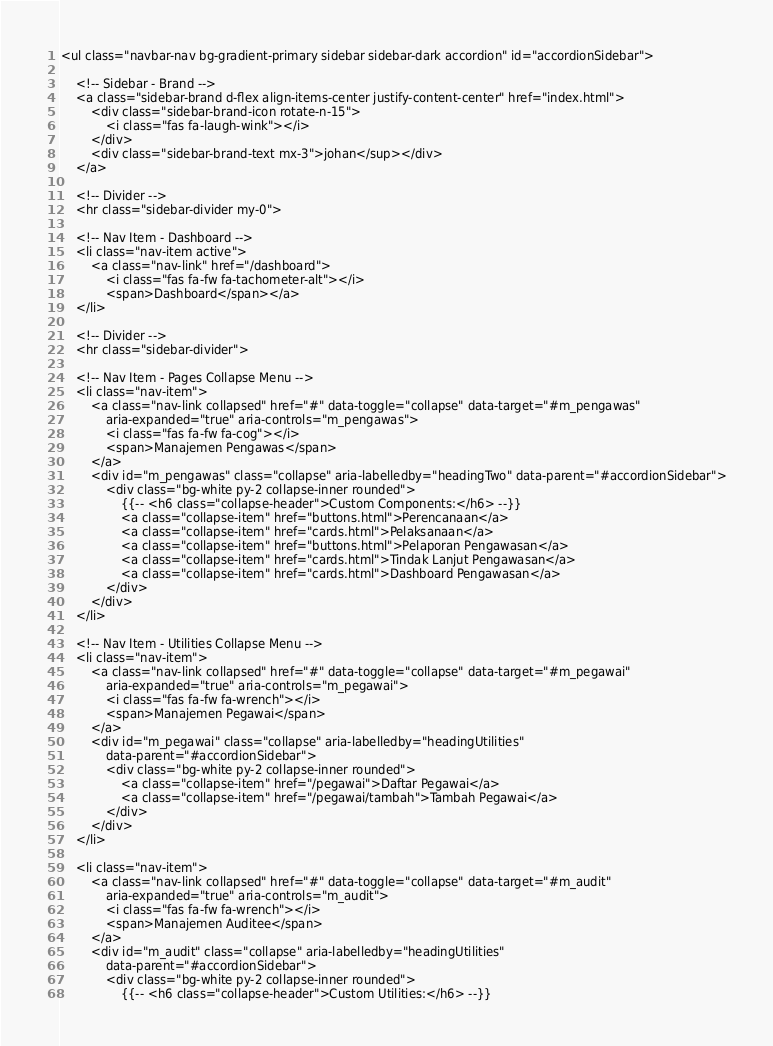<code> <loc_0><loc_0><loc_500><loc_500><_PHP_><ul class="navbar-nav bg-gradient-primary sidebar sidebar-dark accordion" id="accordionSidebar">

    <!-- Sidebar - Brand -->
    <a class="sidebar-brand d-flex align-items-center justify-content-center" href="index.html">
        <div class="sidebar-brand-icon rotate-n-15">
            <i class="fas fa-laugh-wink"></i>
        </div>
        <div class="sidebar-brand-text mx-3">johan</sup></div>
    </a>

    <!-- Divider -->
    <hr class="sidebar-divider my-0">

    <!-- Nav Item - Dashboard -->
    <li class="nav-item active">
        <a class="nav-link" href="/dashboard">
            <i class="fas fa-fw fa-tachometer-alt"></i>
            <span>Dashboard</span></a>
    </li>

    <!-- Divider -->
    <hr class="sidebar-divider">

    <!-- Nav Item - Pages Collapse Menu -->
    <li class="nav-item">
        <a class="nav-link collapsed" href="#" data-toggle="collapse" data-target="#m_pengawas"
            aria-expanded="true" aria-controls="m_pengawas">
            <i class="fas fa-fw fa-cog"></i>
            <span>Manajemen Pengawas</span>
        </a>
        <div id="m_pengawas" class="collapse" aria-labelledby="headingTwo" data-parent="#accordionSidebar">
            <div class="bg-white py-2 collapse-inner rounded">
                {{-- <h6 class="collapse-header">Custom Components:</h6> --}}
                <a class="collapse-item" href="buttons.html">Perencanaan</a>
                <a class="collapse-item" href="cards.html">Pelaksanaan</a>
                <a class="collapse-item" href="buttons.html">Pelaporan Pengawasan</a>
                <a class="collapse-item" href="cards.html">Tindak Lanjut Pengawasan</a>
                <a class="collapse-item" href="cards.html">Dashboard Pengawasan</a>
            </div>
        </div>
    </li>

    <!-- Nav Item - Utilities Collapse Menu -->
    <li class="nav-item">
        <a class="nav-link collapsed" href="#" data-toggle="collapse" data-target="#m_pegawai"
            aria-expanded="true" aria-controls="m_pegawai">
            <i class="fas fa-fw fa-wrench"></i>
            <span>Manajemen Pegawai</span>
        </a>
        <div id="m_pegawai" class="collapse" aria-labelledby="headingUtilities"
            data-parent="#accordionSidebar">
            <div class="bg-white py-2 collapse-inner rounded">
                <a class="collapse-item" href="/pegawai">Daftar Pegawai</a>
                <a class="collapse-item" href="/pegawai/tambah">Tambah Pegawai</a>
            </div>
        </div>
    </li>

    <li class="nav-item">
        <a class="nav-link collapsed" href="#" data-toggle="collapse" data-target="#m_audit"
            aria-expanded="true" aria-controls="m_audit">
            <i class="fas fa-fw fa-wrench"></i>
            <span>Manajemen Auditee</span>
        </a>
        <div id="m_audit" class="collapse" aria-labelledby="headingUtilities"
            data-parent="#accordionSidebar">
            <div class="bg-white py-2 collapse-inner rounded">
                {{-- <h6 class="collapse-header">Custom Utilities:</h6> --}}</code> 